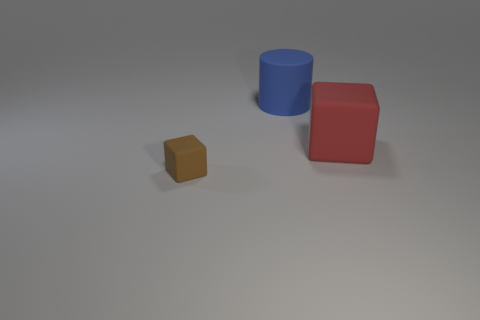Add 3 small red metal objects. How many objects exist? 6 Subtract all cylinders. How many objects are left? 2 Add 2 large blue balls. How many large blue balls exist? 2 Subtract 1 red blocks. How many objects are left? 2 Subtract 1 cubes. How many cubes are left? 1 Subtract all brown cubes. Subtract all brown spheres. How many cubes are left? 1 Subtract all blue cubes. Subtract all brown matte blocks. How many objects are left? 2 Add 1 brown objects. How many brown objects are left? 2 